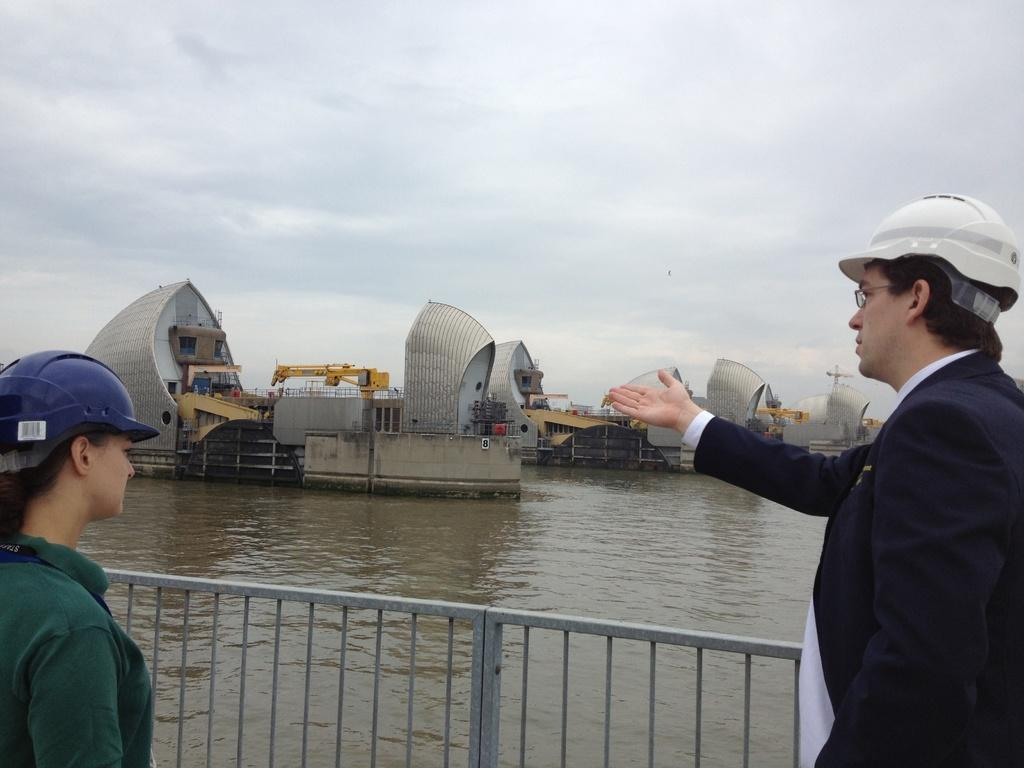What is the man in the image wearing? The man is wearing a helmet. What is the woman in the image wearing? The woman is also wearing a helmet. What can be seen in the background of the image? There is a fence, a water body, a group of buildings, a crane, and a pole visible in the image. How does the sky appear in the image? The sky appears cloudy in the image. What type of knife can be seen in the image? There is no knife present in the image. What arithmetic problem is being solved by the crane in the image? The crane in the image is not solving any arithmetic problem; it is a construction crane. 